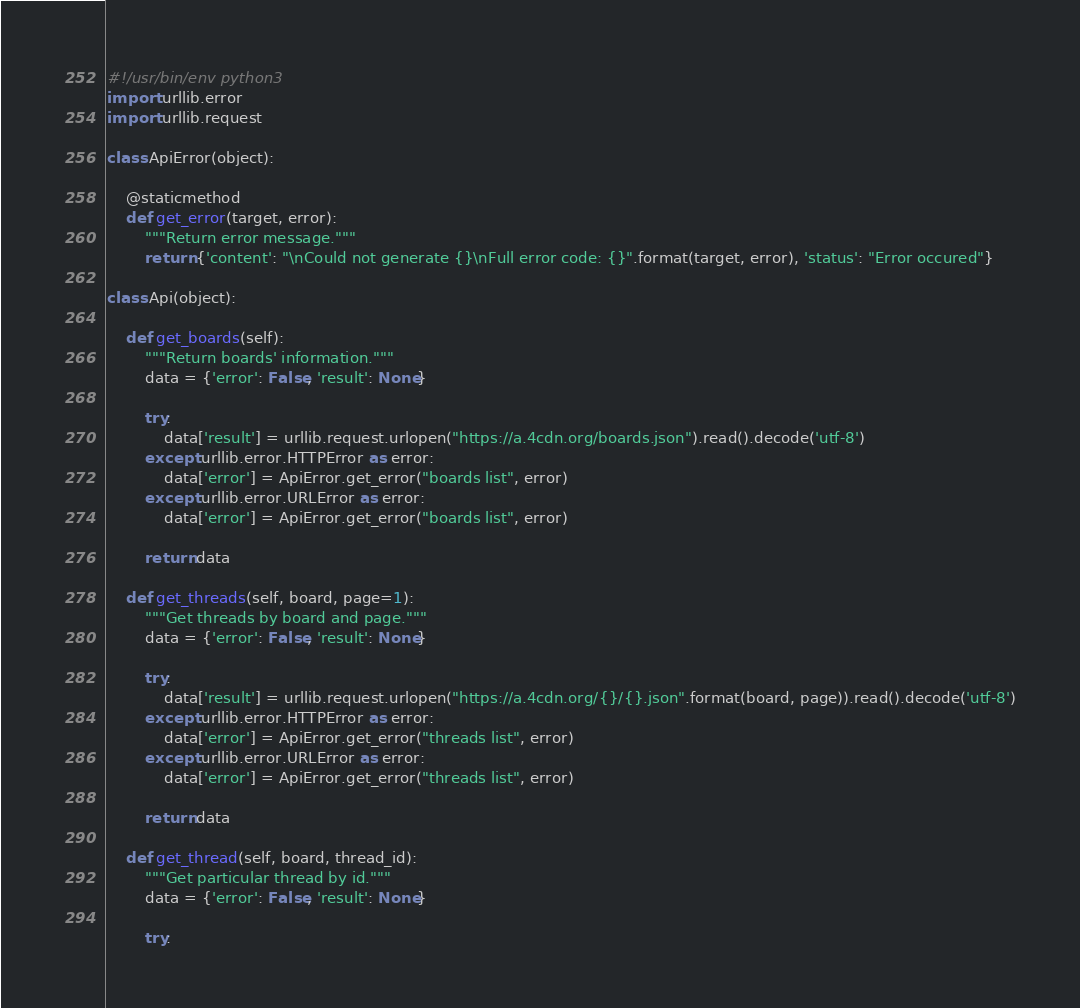Convert code to text. <code><loc_0><loc_0><loc_500><loc_500><_Python_>#!/usr/bin/env python3
import urllib.error
import urllib.request

class ApiError(object):

    @staticmethod
    def get_error(target, error):
        """Return error message."""
        return {'content': "\nCould not generate {}\nFull error code: {}".format(target, error), 'status': "Error occured"}

class Api(object):

    def get_boards(self):
        """Return boards' information."""
        data = {'error': False, 'result': None}

        try:
            data['result'] = urllib.request.urlopen("https://a.4cdn.org/boards.json").read().decode('utf-8')
        except urllib.error.HTTPError as error:
            data['error'] = ApiError.get_error("boards list", error)
        except urllib.error.URLError as error:
            data['error'] = ApiError.get_error("boards list", error)

        return data
    
    def get_threads(self, board, page=1):
        """Get threads by board and page."""
        data = {'error': False, 'result': None}

        try:
            data['result'] = urllib.request.urlopen("https://a.4cdn.org/{}/{}.json".format(board, page)).read().decode('utf-8')
        except urllib.error.HTTPError as error:
            data['error'] = ApiError.get_error("threads list", error)
        except urllib.error.URLError as error:
            data['error'] = ApiError.get_error("threads list", error)

        return data

    def get_thread(self, board, thread_id):
        """Get particular thread by id."""
        data = {'error': False, 'result': None}

        try:</code> 